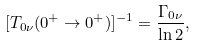Convert formula to latex. <formula><loc_0><loc_0><loc_500><loc_500>[ T _ { 0 \nu } ( 0 ^ { + } \rightarrow 0 ^ { + } ) ] ^ { - 1 } = \frac { \Gamma _ { 0 \nu } } { \ln 2 } ,</formula> 